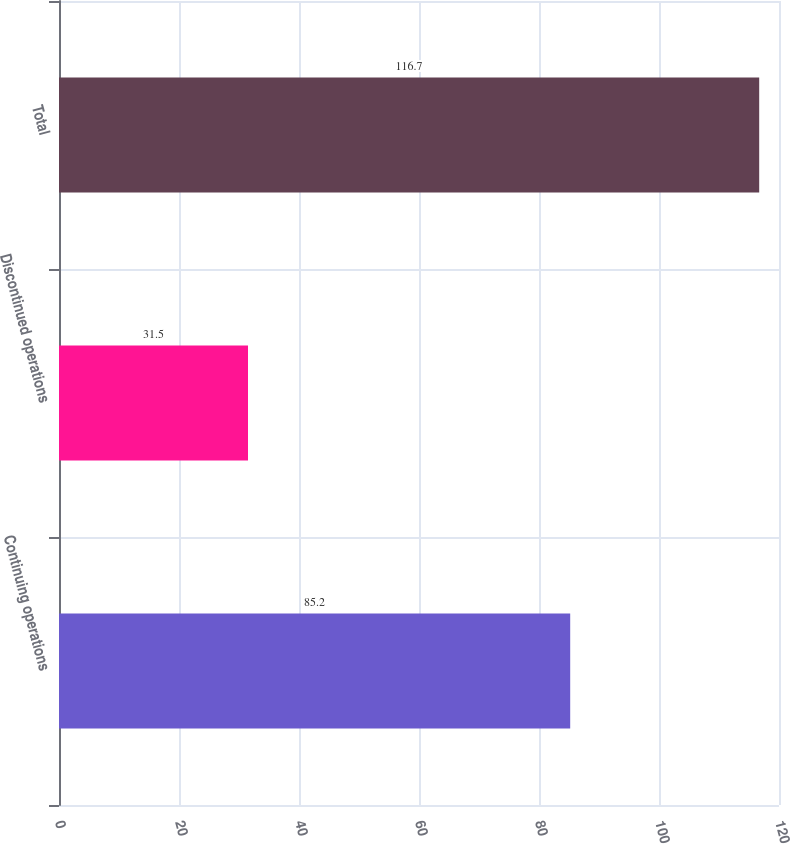<chart> <loc_0><loc_0><loc_500><loc_500><bar_chart><fcel>Continuing operations<fcel>Discontinued operations<fcel>Total<nl><fcel>85.2<fcel>31.5<fcel>116.7<nl></chart> 